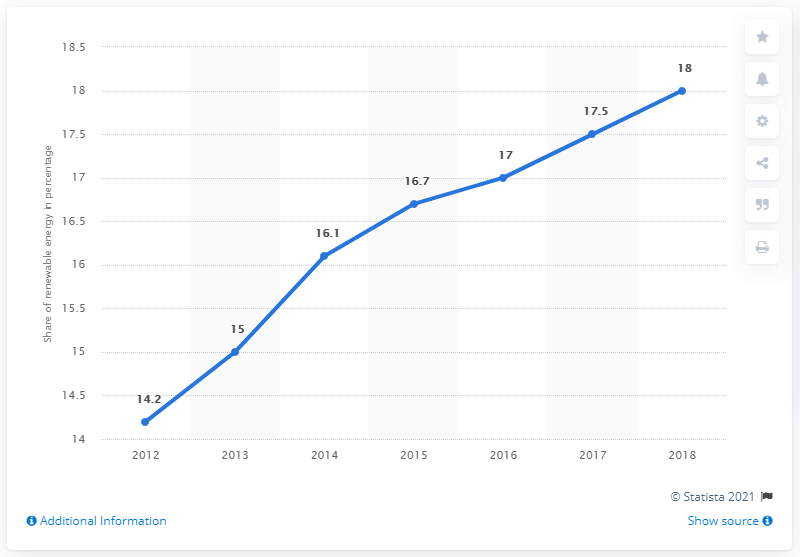Indicate a few pertinent items in this graphic. In the period between 2012 and 2018, renewable sources accounted for 14.2% of the total energy consumed in the country. The average of the last three years is 17.5. Seven years have been taken. In 2018, the share of renewable energy sources in gross final energy consumption reached its peak. 